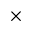<formula> <loc_0><loc_0><loc_500><loc_500>\times</formula> 